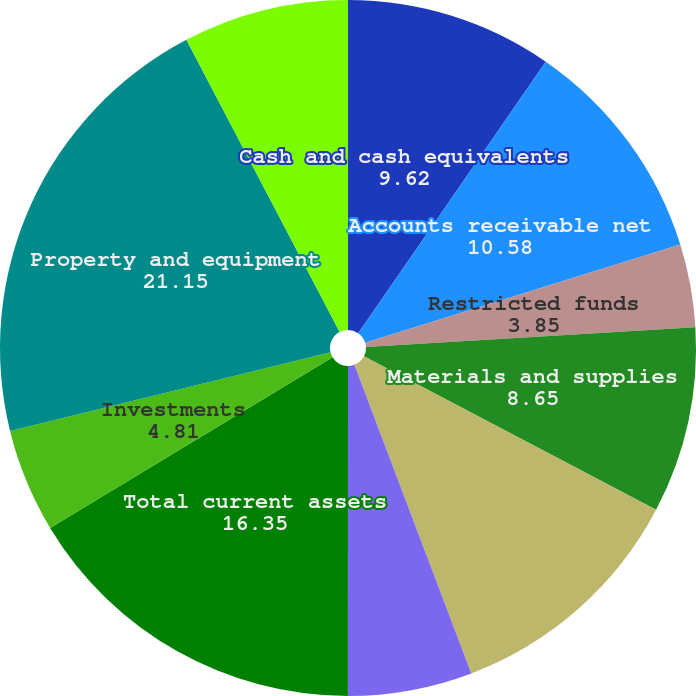<chart> <loc_0><loc_0><loc_500><loc_500><pie_chart><fcel>Cash and cash equivalents<fcel>Accounts receivable net<fcel>Restricted funds<fcel>Materials and supplies<fcel>Deferred income taxes<fcel>Other current assets<fcel>Total current assets<fcel>Investments<fcel>Property and equipment<fcel>Other assets<nl><fcel>9.62%<fcel>10.58%<fcel>3.85%<fcel>8.65%<fcel>11.54%<fcel>5.77%<fcel>16.35%<fcel>4.81%<fcel>21.15%<fcel>7.69%<nl></chart> 